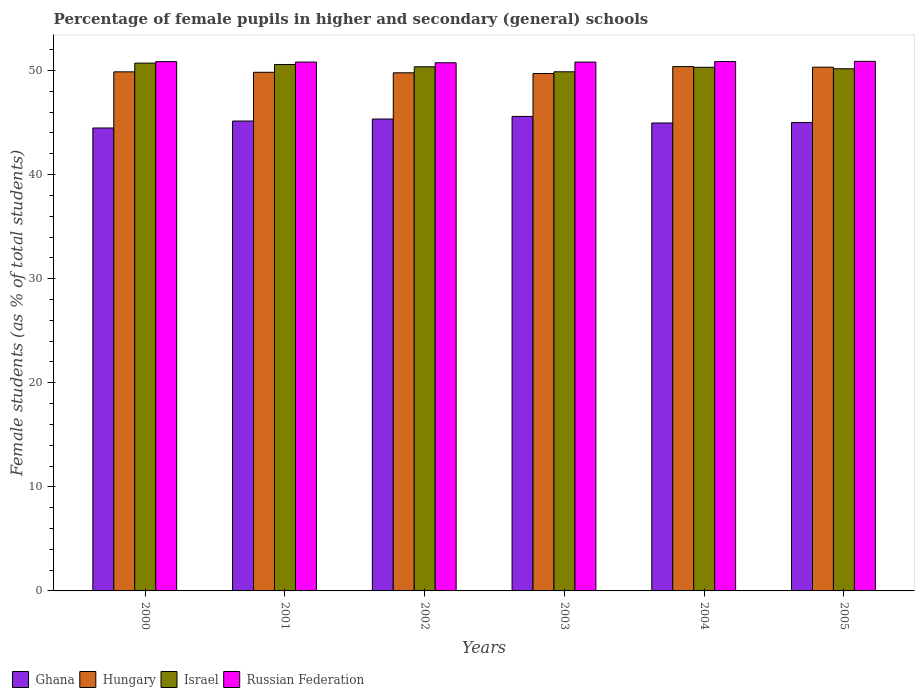What is the percentage of female pupils in higher and secondary schools in Ghana in 2003?
Offer a very short reply. 45.58. Across all years, what is the maximum percentage of female pupils in higher and secondary schools in Ghana?
Your answer should be compact. 45.58. Across all years, what is the minimum percentage of female pupils in higher and secondary schools in Ghana?
Your response must be concise. 44.47. In which year was the percentage of female pupils in higher and secondary schools in Hungary maximum?
Provide a succinct answer. 2004. In which year was the percentage of female pupils in higher and secondary schools in Russian Federation minimum?
Offer a terse response. 2002. What is the total percentage of female pupils in higher and secondary schools in Hungary in the graph?
Offer a very short reply. 299.85. What is the difference between the percentage of female pupils in higher and secondary schools in Hungary in 2000 and that in 2002?
Your answer should be very brief. 0.09. What is the difference between the percentage of female pupils in higher and secondary schools in Hungary in 2001 and the percentage of female pupils in higher and secondary schools in Ghana in 2002?
Offer a terse response. 4.49. What is the average percentage of female pupils in higher and secondary schools in Russian Federation per year?
Give a very brief answer. 50.82. In the year 2003, what is the difference between the percentage of female pupils in higher and secondary schools in Israel and percentage of female pupils in higher and secondary schools in Russian Federation?
Your answer should be very brief. -0.93. In how many years, is the percentage of female pupils in higher and secondary schools in Israel greater than 12 %?
Provide a succinct answer. 6. What is the ratio of the percentage of female pupils in higher and secondary schools in Israel in 2002 to that in 2003?
Provide a short and direct response. 1.01. Is the percentage of female pupils in higher and secondary schools in Israel in 2003 less than that in 2005?
Ensure brevity in your answer.  Yes. Is the difference between the percentage of female pupils in higher and secondary schools in Israel in 2000 and 2001 greater than the difference between the percentage of female pupils in higher and secondary schools in Russian Federation in 2000 and 2001?
Give a very brief answer. Yes. What is the difference between the highest and the second highest percentage of female pupils in higher and secondary schools in Israel?
Offer a very short reply. 0.13. What is the difference between the highest and the lowest percentage of female pupils in higher and secondary schools in Russian Federation?
Offer a terse response. 0.13. What does the 3rd bar from the left in 2003 represents?
Your answer should be very brief. Israel. What does the 1st bar from the right in 2001 represents?
Your response must be concise. Russian Federation. Is it the case that in every year, the sum of the percentage of female pupils in higher and secondary schools in Russian Federation and percentage of female pupils in higher and secondary schools in Hungary is greater than the percentage of female pupils in higher and secondary schools in Israel?
Your answer should be compact. Yes. What is the difference between two consecutive major ticks on the Y-axis?
Make the answer very short. 10. Does the graph contain any zero values?
Provide a short and direct response. No. Where does the legend appear in the graph?
Your answer should be very brief. Bottom left. How are the legend labels stacked?
Your answer should be compact. Horizontal. What is the title of the graph?
Offer a very short reply. Percentage of female pupils in higher and secondary (general) schools. Does "French Polynesia" appear as one of the legend labels in the graph?
Make the answer very short. No. What is the label or title of the X-axis?
Ensure brevity in your answer.  Years. What is the label or title of the Y-axis?
Provide a short and direct response. Female students (as % of total students). What is the Female students (as % of total students) in Ghana in 2000?
Give a very brief answer. 44.47. What is the Female students (as % of total students) of Hungary in 2000?
Provide a short and direct response. 49.87. What is the Female students (as % of total students) in Israel in 2000?
Offer a very short reply. 50.7. What is the Female students (as % of total students) in Russian Federation in 2000?
Provide a short and direct response. 50.85. What is the Female students (as % of total students) of Ghana in 2001?
Offer a terse response. 45.14. What is the Female students (as % of total students) in Hungary in 2001?
Your answer should be compact. 49.82. What is the Female students (as % of total students) of Israel in 2001?
Offer a very short reply. 50.57. What is the Female students (as % of total students) of Russian Federation in 2001?
Your response must be concise. 50.81. What is the Female students (as % of total students) in Ghana in 2002?
Your response must be concise. 45.33. What is the Female students (as % of total students) of Hungary in 2002?
Keep it short and to the point. 49.77. What is the Female students (as % of total students) in Israel in 2002?
Offer a terse response. 50.35. What is the Female students (as % of total students) of Russian Federation in 2002?
Ensure brevity in your answer.  50.74. What is the Female students (as % of total students) in Ghana in 2003?
Ensure brevity in your answer.  45.58. What is the Female students (as % of total students) of Hungary in 2003?
Provide a succinct answer. 49.71. What is the Female students (as % of total students) in Israel in 2003?
Your response must be concise. 49.87. What is the Female students (as % of total students) of Russian Federation in 2003?
Provide a short and direct response. 50.8. What is the Female students (as % of total students) of Ghana in 2004?
Offer a terse response. 44.95. What is the Female students (as % of total students) of Hungary in 2004?
Your answer should be compact. 50.37. What is the Female students (as % of total students) in Israel in 2004?
Your answer should be compact. 50.3. What is the Female students (as % of total students) of Russian Federation in 2004?
Provide a succinct answer. 50.85. What is the Female students (as % of total students) in Ghana in 2005?
Ensure brevity in your answer.  45. What is the Female students (as % of total students) in Hungary in 2005?
Ensure brevity in your answer.  50.31. What is the Female students (as % of total students) of Israel in 2005?
Give a very brief answer. 50.16. What is the Female students (as % of total students) in Russian Federation in 2005?
Provide a short and direct response. 50.87. Across all years, what is the maximum Female students (as % of total students) in Ghana?
Ensure brevity in your answer.  45.58. Across all years, what is the maximum Female students (as % of total students) in Hungary?
Provide a short and direct response. 50.37. Across all years, what is the maximum Female students (as % of total students) of Israel?
Your answer should be very brief. 50.7. Across all years, what is the maximum Female students (as % of total students) in Russian Federation?
Ensure brevity in your answer.  50.87. Across all years, what is the minimum Female students (as % of total students) of Ghana?
Your answer should be very brief. 44.47. Across all years, what is the minimum Female students (as % of total students) of Hungary?
Keep it short and to the point. 49.71. Across all years, what is the minimum Female students (as % of total students) of Israel?
Your response must be concise. 49.87. Across all years, what is the minimum Female students (as % of total students) of Russian Federation?
Your response must be concise. 50.74. What is the total Female students (as % of total students) in Ghana in the graph?
Your answer should be compact. 270.48. What is the total Female students (as % of total students) of Hungary in the graph?
Keep it short and to the point. 299.85. What is the total Female students (as % of total students) of Israel in the graph?
Keep it short and to the point. 301.96. What is the total Female students (as % of total students) in Russian Federation in the graph?
Ensure brevity in your answer.  304.93. What is the difference between the Female students (as % of total students) in Ghana in 2000 and that in 2001?
Give a very brief answer. -0.67. What is the difference between the Female students (as % of total students) in Hungary in 2000 and that in 2001?
Provide a succinct answer. 0.04. What is the difference between the Female students (as % of total students) of Israel in 2000 and that in 2001?
Your answer should be very brief. 0.13. What is the difference between the Female students (as % of total students) in Russian Federation in 2000 and that in 2001?
Provide a short and direct response. 0.04. What is the difference between the Female students (as % of total students) in Ghana in 2000 and that in 2002?
Offer a terse response. -0.86. What is the difference between the Female students (as % of total students) in Hungary in 2000 and that in 2002?
Your answer should be very brief. 0.09. What is the difference between the Female students (as % of total students) of Israel in 2000 and that in 2002?
Your answer should be very brief. 0.35. What is the difference between the Female students (as % of total students) in Russian Federation in 2000 and that in 2002?
Your answer should be very brief. 0.11. What is the difference between the Female students (as % of total students) of Ghana in 2000 and that in 2003?
Ensure brevity in your answer.  -1.11. What is the difference between the Female students (as % of total students) of Hungary in 2000 and that in 2003?
Ensure brevity in your answer.  0.16. What is the difference between the Female students (as % of total students) of Russian Federation in 2000 and that in 2003?
Your answer should be very brief. 0.05. What is the difference between the Female students (as % of total students) of Ghana in 2000 and that in 2004?
Your answer should be very brief. -0.48. What is the difference between the Female students (as % of total students) in Hungary in 2000 and that in 2004?
Your answer should be compact. -0.5. What is the difference between the Female students (as % of total students) in Israel in 2000 and that in 2004?
Provide a succinct answer. 0.4. What is the difference between the Female students (as % of total students) in Russian Federation in 2000 and that in 2004?
Make the answer very short. -0. What is the difference between the Female students (as % of total students) in Ghana in 2000 and that in 2005?
Give a very brief answer. -0.53. What is the difference between the Female students (as % of total students) in Hungary in 2000 and that in 2005?
Make the answer very short. -0.45. What is the difference between the Female students (as % of total students) in Israel in 2000 and that in 2005?
Ensure brevity in your answer.  0.54. What is the difference between the Female students (as % of total students) in Russian Federation in 2000 and that in 2005?
Ensure brevity in your answer.  -0.02. What is the difference between the Female students (as % of total students) of Ghana in 2001 and that in 2002?
Offer a terse response. -0.19. What is the difference between the Female students (as % of total students) in Hungary in 2001 and that in 2002?
Make the answer very short. 0.05. What is the difference between the Female students (as % of total students) of Israel in 2001 and that in 2002?
Offer a terse response. 0.22. What is the difference between the Female students (as % of total students) of Russian Federation in 2001 and that in 2002?
Keep it short and to the point. 0.07. What is the difference between the Female students (as % of total students) in Ghana in 2001 and that in 2003?
Your answer should be compact. -0.44. What is the difference between the Female students (as % of total students) in Hungary in 2001 and that in 2003?
Make the answer very short. 0.12. What is the difference between the Female students (as % of total students) in Israel in 2001 and that in 2003?
Provide a short and direct response. 0.7. What is the difference between the Female students (as % of total students) of Russian Federation in 2001 and that in 2003?
Provide a short and direct response. 0. What is the difference between the Female students (as % of total students) of Ghana in 2001 and that in 2004?
Provide a succinct answer. 0.19. What is the difference between the Female students (as % of total students) in Hungary in 2001 and that in 2004?
Your answer should be very brief. -0.55. What is the difference between the Female students (as % of total students) in Israel in 2001 and that in 2004?
Give a very brief answer. 0.27. What is the difference between the Female students (as % of total students) in Russian Federation in 2001 and that in 2004?
Provide a short and direct response. -0.05. What is the difference between the Female students (as % of total students) of Ghana in 2001 and that in 2005?
Give a very brief answer. 0.14. What is the difference between the Female students (as % of total students) in Hungary in 2001 and that in 2005?
Your answer should be very brief. -0.49. What is the difference between the Female students (as % of total students) in Israel in 2001 and that in 2005?
Your answer should be compact. 0.41. What is the difference between the Female students (as % of total students) of Russian Federation in 2001 and that in 2005?
Provide a short and direct response. -0.07. What is the difference between the Female students (as % of total students) of Ghana in 2002 and that in 2003?
Your response must be concise. -0.25. What is the difference between the Female students (as % of total students) of Hungary in 2002 and that in 2003?
Provide a short and direct response. 0.07. What is the difference between the Female students (as % of total students) in Israel in 2002 and that in 2003?
Provide a succinct answer. 0.48. What is the difference between the Female students (as % of total students) in Russian Federation in 2002 and that in 2003?
Keep it short and to the point. -0.06. What is the difference between the Female students (as % of total students) of Ghana in 2002 and that in 2004?
Ensure brevity in your answer.  0.38. What is the difference between the Female students (as % of total students) of Hungary in 2002 and that in 2004?
Your answer should be compact. -0.6. What is the difference between the Female students (as % of total students) in Israel in 2002 and that in 2004?
Your answer should be compact. 0.05. What is the difference between the Female students (as % of total students) of Russian Federation in 2002 and that in 2004?
Keep it short and to the point. -0.11. What is the difference between the Female students (as % of total students) of Ghana in 2002 and that in 2005?
Keep it short and to the point. 0.33. What is the difference between the Female students (as % of total students) of Hungary in 2002 and that in 2005?
Your answer should be very brief. -0.54. What is the difference between the Female students (as % of total students) in Israel in 2002 and that in 2005?
Your answer should be compact. 0.19. What is the difference between the Female students (as % of total students) of Russian Federation in 2002 and that in 2005?
Your answer should be very brief. -0.13. What is the difference between the Female students (as % of total students) in Ghana in 2003 and that in 2004?
Your answer should be compact. 0.63. What is the difference between the Female students (as % of total students) in Hungary in 2003 and that in 2004?
Provide a succinct answer. -0.66. What is the difference between the Female students (as % of total students) of Israel in 2003 and that in 2004?
Your answer should be compact. -0.43. What is the difference between the Female students (as % of total students) in Russian Federation in 2003 and that in 2004?
Your response must be concise. -0.05. What is the difference between the Female students (as % of total students) in Ghana in 2003 and that in 2005?
Keep it short and to the point. 0.58. What is the difference between the Female students (as % of total students) in Hungary in 2003 and that in 2005?
Your answer should be very brief. -0.61. What is the difference between the Female students (as % of total students) in Israel in 2003 and that in 2005?
Ensure brevity in your answer.  -0.29. What is the difference between the Female students (as % of total students) in Russian Federation in 2003 and that in 2005?
Provide a succinct answer. -0.07. What is the difference between the Female students (as % of total students) of Ghana in 2004 and that in 2005?
Offer a very short reply. -0.05. What is the difference between the Female students (as % of total students) in Hungary in 2004 and that in 2005?
Your answer should be very brief. 0.06. What is the difference between the Female students (as % of total students) in Israel in 2004 and that in 2005?
Give a very brief answer. 0.14. What is the difference between the Female students (as % of total students) of Russian Federation in 2004 and that in 2005?
Keep it short and to the point. -0.02. What is the difference between the Female students (as % of total students) in Ghana in 2000 and the Female students (as % of total students) in Hungary in 2001?
Provide a short and direct response. -5.35. What is the difference between the Female students (as % of total students) of Ghana in 2000 and the Female students (as % of total students) of Israel in 2001?
Your answer should be very brief. -6.1. What is the difference between the Female students (as % of total students) of Ghana in 2000 and the Female students (as % of total students) of Russian Federation in 2001?
Give a very brief answer. -6.33. What is the difference between the Female students (as % of total students) in Hungary in 2000 and the Female students (as % of total students) in Israel in 2001?
Provide a succinct answer. -0.71. What is the difference between the Female students (as % of total students) of Hungary in 2000 and the Female students (as % of total students) of Russian Federation in 2001?
Ensure brevity in your answer.  -0.94. What is the difference between the Female students (as % of total students) in Israel in 2000 and the Female students (as % of total students) in Russian Federation in 2001?
Provide a short and direct response. -0.1. What is the difference between the Female students (as % of total students) in Ghana in 2000 and the Female students (as % of total students) in Hungary in 2002?
Give a very brief answer. -5.3. What is the difference between the Female students (as % of total students) in Ghana in 2000 and the Female students (as % of total students) in Israel in 2002?
Provide a succinct answer. -5.88. What is the difference between the Female students (as % of total students) of Ghana in 2000 and the Female students (as % of total students) of Russian Federation in 2002?
Keep it short and to the point. -6.27. What is the difference between the Female students (as % of total students) in Hungary in 2000 and the Female students (as % of total students) in Israel in 2002?
Your response must be concise. -0.49. What is the difference between the Female students (as % of total students) in Hungary in 2000 and the Female students (as % of total students) in Russian Federation in 2002?
Offer a very short reply. -0.88. What is the difference between the Female students (as % of total students) in Israel in 2000 and the Female students (as % of total students) in Russian Federation in 2002?
Give a very brief answer. -0.04. What is the difference between the Female students (as % of total students) in Ghana in 2000 and the Female students (as % of total students) in Hungary in 2003?
Keep it short and to the point. -5.23. What is the difference between the Female students (as % of total students) of Ghana in 2000 and the Female students (as % of total students) of Israel in 2003?
Your response must be concise. -5.4. What is the difference between the Female students (as % of total students) of Ghana in 2000 and the Female students (as % of total students) of Russian Federation in 2003?
Make the answer very short. -6.33. What is the difference between the Female students (as % of total students) of Hungary in 2000 and the Female students (as % of total students) of Israel in 2003?
Provide a short and direct response. -0. What is the difference between the Female students (as % of total students) in Hungary in 2000 and the Female students (as % of total students) in Russian Federation in 2003?
Your answer should be very brief. -0.94. What is the difference between the Female students (as % of total students) in Israel in 2000 and the Female students (as % of total students) in Russian Federation in 2003?
Ensure brevity in your answer.  -0.1. What is the difference between the Female students (as % of total students) in Ghana in 2000 and the Female students (as % of total students) in Hungary in 2004?
Your response must be concise. -5.9. What is the difference between the Female students (as % of total students) of Ghana in 2000 and the Female students (as % of total students) of Israel in 2004?
Provide a short and direct response. -5.83. What is the difference between the Female students (as % of total students) in Ghana in 2000 and the Female students (as % of total students) in Russian Federation in 2004?
Keep it short and to the point. -6.38. What is the difference between the Female students (as % of total students) of Hungary in 2000 and the Female students (as % of total students) of Israel in 2004?
Your response must be concise. -0.44. What is the difference between the Female students (as % of total students) of Hungary in 2000 and the Female students (as % of total students) of Russian Federation in 2004?
Keep it short and to the point. -0.99. What is the difference between the Female students (as % of total students) in Israel in 2000 and the Female students (as % of total students) in Russian Federation in 2004?
Give a very brief answer. -0.15. What is the difference between the Female students (as % of total students) of Ghana in 2000 and the Female students (as % of total students) of Hungary in 2005?
Make the answer very short. -5.84. What is the difference between the Female students (as % of total students) in Ghana in 2000 and the Female students (as % of total students) in Israel in 2005?
Keep it short and to the point. -5.69. What is the difference between the Female students (as % of total students) in Ghana in 2000 and the Female students (as % of total students) in Russian Federation in 2005?
Give a very brief answer. -6.4. What is the difference between the Female students (as % of total students) in Hungary in 2000 and the Female students (as % of total students) in Israel in 2005?
Give a very brief answer. -0.3. What is the difference between the Female students (as % of total students) of Hungary in 2000 and the Female students (as % of total students) of Russian Federation in 2005?
Your response must be concise. -1.01. What is the difference between the Female students (as % of total students) of Israel in 2000 and the Female students (as % of total students) of Russian Federation in 2005?
Keep it short and to the point. -0.17. What is the difference between the Female students (as % of total students) in Ghana in 2001 and the Female students (as % of total students) in Hungary in 2002?
Offer a terse response. -4.63. What is the difference between the Female students (as % of total students) in Ghana in 2001 and the Female students (as % of total students) in Israel in 2002?
Provide a succinct answer. -5.21. What is the difference between the Female students (as % of total students) in Ghana in 2001 and the Female students (as % of total students) in Russian Federation in 2002?
Provide a succinct answer. -5.6. What is the difference between the Female students (as % of total students) of Hungary in 2001 and the Female students (as % of total students) of Israel in 2002?
Your answer should be compact. -0.53. What is the difference between the Female students (as % of total students) of Hungary in 2001 and the Female students (as % of total students) of Russian Federation in 2002?
Your answer should be compact. -0.92. What is the difference between the Female students (as % of total students) of Israel in 2001 and the Female students (as % of total students) of Russian Federation in 2002?
Give a very brief answer. -0.17. What is the difference between the Female students (as % of total students) of Ghana in 2001 and the Female students (as % of total students) of Hungary in 2003?
Your answer should be very brief. -4.57. What is the difference between the Female students (as % of total students) of Ghana in 2001 and the Female students (as % of total students) of Israel in 2003?
Keep it short and to the point. -4.73. What is the difference between the Female students (as % of total students) of Ghana in 2001 and the Female students (as % of total students) of Russian Federation in 2003?
Provide a short and direct response. -5.66. What is the difference between the Female students (as % of total students) of Hungary in 2001 and the Female students (as % of total students) of Israel in 2003?
Your answer should be very brief. -0.05. What is the difference between the Female students (as % of total students) in Hungary in 2001 and the Female students (as % of total students) in Russian Federation in 2003?
Your answer should be compact. -0.98. What is the difference between the Female students (as % of total students) of Israel in 2001 and the Female students (as % of total students) of Russian Federation in 2003?
Offer a very short reply. -0.23. What is the difference between the Female students (as % of total students) of Ghana in 2001 and the Female students (as % of total students) of Hungary in 2004?
Offer a very short reply. -5.23. What is the difference between the Female students (as % of total students) of Ghana in 2001 and the Female students (as % of total students) of Israel in 2004?
Give a very brief answer. -5.16. What is the difference between the Female students (as % of total students) in Ghana in 2001 and the Female students (as % of total students) in Russian Federation in 2004?
Offer a terse response. -5.71. What is the difference between the Female students (as % of total students) of Hungary in 2001 and the Female students (as % of total students) of Israel in 2004?
Provide a short and direct response. -0.48. What is the difference between the Female students (as % of total students) of Hungary in 2001 and the Female students (as % of total students) of Russian Federation in 2004?
Provide a succinct answer. -1.03. What is the difference between the Female students (as % of total students) of Israel in 2001 and the Female students (as % of total students) of Russian Federation in 2004?
Your answer should be very brief. -0.28. What is the difference between the Female students (as % of total students) in Ghana in 2001 and the Female students (as % of total students) in Hungary in 2005?
Your answer should be very brief. -5.17. What is the difference between the Female students (as % of total students) in Ghana in 2001 and the Female students (as % of total students) in Israel in 2005?
Your answer should be compact. -5.02. What is the difference between the Female students (as % of total students) in Ghana in 2001 and the Female students (as % of total students) in Russian Federation in 2005?
Keep it short and to the point. -5.73. What is the difference between the Female students (as % of total students) in Hungary in 2001 and the Female students (as % of total students) in Israel in 2005?
Ensure brevity in your answer.  -0.34. What is the difference between the Female students (as % of total students) in Hungary in 2001 and the Female students (as % of total students) in Russian Federation in 2005?
Keep it short and to the point. -1.05. What is the difference between the Female students (as % of total students) in Israel in 2001 and the Female students (as % of total students) in Russian Federation in 2005?
Offer a terse response. -0.3. What is the difference between the Female students (as % of total students) of Ghana in 2002 and the Female students (as % of total students) of Hungary in 2003?
Give a very brief answer. -4.37. What is the difference between the Female students (as % of total students) of Ghana in 2002 and the Female students (as % of total students) of Israel in 2003?
Keep it short and to the point. -4.54. What is the difference between the Female students (as % of total students) of Ghana in 2002 and the Female students (as % of total students) of Russian Federation in 2003?
Give a very brief answer. -5.47. What is the difference between the Female students (as % of total students) in Hungary in 2002 and the Female students (as % of total students) in Israel in 2003?
Offer a terse response. -0.1. What is the difference between the Female students (as % of total students) of Hungary in 2002 and the Female students (as % of total students) of Russian Federation in 2003?
Keep it short and to the point. -1.03. What is the difference between the Female students (as % of total students) in Israel in 2002 and the Female students (as % of total students) in Russian Federation in 2003?
Your answer should be very brief. -0.45. What is the difference between the Female students (as % of total students) of Ghana in 2002 and the Female students (as % of total students) of Hungary in 2004?
Keep it short and to the point. -5.04. What is the difference between the Female students (as % of total students) of Ghana in 2002 and the Female students (as % of total students) of Israel in 2004?
Your answer should be compact. -4.97. What is the difference between the Female students (as % of total students) in Ghana in 2002 and the Female students (as % of total students) in Russian Federation in 2004?
Ensure brevity in your answer.  -5.52. What is the difference between the Female students (as % of total students) in Hungary in 2002 and the Female students (as % of total students) in Israel in 2004?
Make the answer very short. -0.53. What is the difference between the Female students (as % of total students) in Hungary in 2002 and the Female students (as % of total students) in Russian Federation in 2004?
Your answer should be compact. -1.08. What is the difference between the Female students (as % of total students) in Israel in 2002 and the Female students (as % of total students) in Russian Federation in 2004?
Provide a succinct answer. -0.5. What is the difference between the Female students (as % of total students) of Ghana in 2002 and the Female students (as % of total students) of Hungary in 2005?
Your answer should be compact. -4.98. What is the difference between the Female students (as % of total students) of Ghana in 2002 and the Female students (as % of total students) of Israel in 2005?
Ensure brevity in your answer.  -4.83. What is the difference between the Female students (as % of total students) in Ghana in 2002 and the Female students (as % of total students) in Russian Federation in 2005?
Keep it short and to the point. -5.54. What is the difference between the Female students (as % of total students) in Hungary in 2002 and the Female students (as % of total students) in Israel in 2005?
Provide a succinct answer. -0.39. What is the difference between the Female students (as % of total students) of Hungary in 2002 and the Female students (as % of total students) of Russian Federation in 2005?
Give a very brief answer. -1.1. What is the difference between the Female students (as % of total students) in Israel in 2002 and the Female students (as % of total students) in Russian Federation in 2005?
Your answer should be very brief. -0.52. What is the difference between the Female students (as % of total students) in Ghana in 2003 and the Female students (as % of total students) in Hungary in 2004?
Your answer should be very brief. -4.79. What is the difference between the Female students (as % of total students) in Ghana in 2003 and the Female students (as % of total students) in Israel in 2004?
Ensure brevity in your answer.  -4.72. What is the difference between the Female students (as % of total students) in Ghana in 2003 and the Female students (as % of total students) in Russian Federation in 2004?
Ensure brevity in your answer.  -5.27. What is the difference between the Female students (as % of total students) in Hungary in 2003 and the Female students (as % of total students) in Israel in 2004?
Your answer should be compact. -0.6. What is the difference between the Female students (as % of total students) in Hungary in 2003 and the Female students (as % of total students) in Russian Federation in 2004?
Offer a very short reply. -1.15. What is the difference between the Female students (as % of total students) in Israel in 2003 and the Female students (as % of total students) in Russian Federation in 2004?
Offer a terse response. -0.98. What is the difference between the Female students (as % of total students) of Ghana in 2003 and the Female students (as % of total students) of Hungary in 2005?
Provide a succinct answer. -4.73. What is the difference between the Female students (as % of total students) of Ghana in 2003 and the Female students (as % of total students) of Israel in 2005?
Ensure brevity in your answer.  -4.58. What is the difference between the Female students (as % of total students) in Ghana in 2003 and the Female students (as % of total students) in Russian Federation in 2005?
Provide a short and direct response. -5.29. What is the difference between the Female students (as % of total students) in Hungary in 2003 and the Female students (as % of total students) in Israel in 2005?
Your answer should be compact. -0.46. What is the difference between the Female students (as % of total students) in Hungary in 2003 and the Female students (as % of total students) in Russian Federation in 2005?
Your response must be concise. -1.17. What is the difference between the Female students (as % of total students) in Israel in 2003 and the Female students (as % of total students) in Russian Federation in 2005?
Your answer should be compact. -1. What is the difference between the Female students (as % of total students) of Ghana in 2004 and the Female students (as % of total students) of Hungary in 2005?
Make the answer very short. -5.36. What is the difference between the Female students (as % of total students) of Ghana in 2004 and the Female students (as % of total students) of Israel in 2005?
Keep it short and to the point. -5.21. What is the difference between the Female students (as % of total students) in Ghana in 2004 and the Female students (as % of total students) in Russian Federation in 2005?
Offer a very short reply. -5.92. What is the difference between the Female students (as % of total students) of Hungary in 2004 and the Female students (as % of total students) of Israel in 2005?
Give a very brief answer. 0.21. What is the difference between the Female students (as % of total students) in Hungary in 2004 and the Female students (as % of total students) in Russian Federation in 2005?
Make the answer very short. -0.5. What is the difference between the Female students (as % of total students) in Israel in 2004 and the Female students (as % of total students) in Russian Federation in 2005?
Ensure brevity in your answer.  -0.57. What is the average Female students (as % of total students) in Ghana per year?
Offer a terse response. 45.08. What is the average Female students (as % of total students) in Hungary per year?
Give a very brief answer. 49.98. What is the average Female students (as % of total students) in Israel per year?
Your answer should be compact. 50.33. What is the average Female students (as % of total students) of Russian Federation per year?
Provide a succinct answer. 50.82. In the year 2000, what is the difference between the Female students (as % of total students) of Ghana and Female students (as % of total students) of Hungary?
Your answer should be very brief. -5.39. In the year 2000, what is the difference between the Female students (as % of total students) in Ghana and Female students (as % of total students) in Israel?
Give a very brief answer. -6.23. In the year 2000, what is the difference between the Female students (as % of total students) in Ghana and Female students (as % of total students) in Russian Federation?
Offer a terse response. -6.38. In the year 2000, what is the difference between the Female students (as % of total students) in Hungary and Female students (as % of total students) in Israel?
Make the answer very short. -0.84. In the year 2000, what is the difference between the Female students (as % of total students) in Hungary and Female students (as % of total students) in Russian Federation?
Offer a very short reply. -0.98. In the year 2000, what is the difference between the Female students (as % of total students) of Israel and Female students (as % of total students) of Russian Federation?
Ensure brevity in your answer.  -0.15. In the year 2001, what is the difference between the Female students (as % of total students) of Ghana and Female students (as % of total students) of Hungary?
Keep it short and to the point. -4.68. In the year 2001, what is the difference between the Female students (as % of total students) in Ghana and Female students (as % of total students) in Israel?
Provide a short and direct response. -5.43. In the year 2001, what is the difference between the Female students (as % of total students) of Ghana and Female students (as % of total students) of Russian Federation?
Provide a short and direct response. -5.67. In the year 2001, what is the difference between the Female students (as % of total students) in Hungary and Female students (as % of total students) in Israel?
Provide a short and direct response. -0.75. In the year 2001, what is the difference between the Female students (as % of total students) in Hungary and Female students (as % of total students) in Russian Federation?
Make the answer very short. -0.98. In the year 2001, what is the difference between the Female students (as % of total students) of Israel and Female students (as % of total students) of Russian Federation?
Offer a very short reply. -0.23. In the year 2002, what is the difference between the Female students (as % of total students) in Ghana and Female students (as % of total students) in Hungary?
Give a very brief answer. -4.44. In the year 2002, what is the difference between the Female students (as % of total students) in Ghana and Female students (as % of total students) in Israel?
Offer a very short reply. -5.02. In the year 2002, what is the difference between the Female students (as % of total students) of Ghana and Female students (as % of total students) of Russian Federation?
Offer a very short reply. -5.41. In the year 2002, what is the difference between the Female students (as % of total students) in Hungary and Female students (as % of total students) in Israel?
Your answer should be very brief. -0.58. In the year 2002, what is the difference between the Female students (as % of total students) of Hungary and Female students (as % of total students) of Russian Federation?
Keep it short and to the point. -0.97. In the year 2002, what is the difference between the Female students (as % of total students) of Israel and Female students (as % of total students) of Russian Federation?
Ensure brevity in your answer.  -0.39. In the year 2003, what is the difference between the Female students (as % of total students) of Ghana and Female students (as % of total students) of Hungary?
Offer a very short reply. -4.12. In the year 2003, what is the difference between the Female students (as % of total students) in Ghana and Female students (as % of total students) in Israel?
Your answer should be compact. -4.29. In the year 2003, what is the difference between the Female students (as % of total students) in Ghana and Female students (as % of total students) in Russian Federation?
Your answer should be very brief. -5.22. In the year 2003, what is the difference between the Female students (as % of total students) of Hungary and Female students (as % of total students) of Israel?
Ensure brevity in your answer.  -0.16. In the year 2003, what is the difference between the Female students (as % of total students) of Hungary and Female students (as % of total students) of Russian Federation?
Your response must be concise. -1.1. In the year 2003, what is the difference between the Female students (as % of total students) of Israel and Female students (as % of total students) of Russian Federation?
Your response must be concise. -0.93. In the year 2004, what is the difference between the Female students (as % of total students) in Ghana and Female students (as % of total students) in Hungary?
Provide a succinct answer. -5.42. In the year 2004, what is the difference between the Female students (as % of total students) in Ghana and Female students (as % of total students) in Israel?
Your answer should be compact. -5.35. In the year 2004, what is the difference between the Female students (as % of total students) in Ghana and Female students (as % of total students) in Russian Federation?
Keep it short and to the point. -5.9. In the year 2004, what is the difference between the Female students (as % of total students) in Hungary and Female students (as % of total students) in Israel?
Keep it short and to the point. 0.07. In the year 2004, what is the difference between the Female students (as % of total students) in Hungary and Female students (as % of total students) in Russian Federation?
Give a very brief answer. -0.48. In the year 2004, what is the difference between the Female students (as % of total students) of Israel and Female students (as % of total students) of Russian Federation?
Give a very brief answer. -0.55. In the year 2005, what is the difference between the Female students (as % of total students) in Ghana and Female students (as % of total students) in Hungary?
Your answer should be compact. -5.31. In the year 2005, what is the difference between the Female students (as % of total students) in Ghana and Female students (as % of total students) in Israel?
Your response must be concise. -5.16. In the year 2005, what is the difference between the Female students (as % of total students) in Ghana and Female students (as % of total students) in Russian Federation?
Your answer should be very brief. -5.87. In the year 2005, what is the difference between the Female students (as % of total students) of Hungary and Female students (as % of total students) of Israel?
Your answer should be very brief. 0.15. In the year 2005, what is the difference between the Female students (as % of total students) in Hungary and Female students (as % of total students) in Russian Federation?
Keep it short and to the point. -0.56. In the year 2005, what is the difference between the Female students (as % of total students) in Israel and Female students (as % of total students) in Russian Federation?
Make the answer very short. -0.71. What is the ratio of the Female students (as % of total students) of Ghana in 2000 to that in 2001?
Make the answer very short. 0.99. What is the ratio of the Female students (as % of total students) in Hungary in 2000 to that in 2001?
Provide a short and direct response. 1. What is the ratio of the Female students (as % of total students) in Russian Federation in 2000 to that in 2001?
Provide a succinct answer. 1. What is the ratio of the Female students (as % of total students) in Ghana in 2000 to that in 2002?
Keep it short and to the point. 0.98. What is the ratio of the Female students (as % of total students) of Israel in 2000 to that in 2002?
Your response must be concise. 1.01. What is the ratio of the Female students (as % of total students) in Russian Federation in 2000 to that in 2002?
Make the answer very short. 1. What is the ratio of the Female students (as % of total students) in Ghana in 2000 to that in 2003?
Your answer should be very brief. 0.98. What is the ratio of the Female students (as % of total students) in Hungary in 2000 to that in 2003?
Offer a terse response. 1. What is the ratio of the Female students (as % of total students) of Israel in 2000 to that in 2003?
Provide a succinct answer. 1.02. What is the ratio of the Female students (as % of total students) in Russian Federation in 2000 to that in 2003?
Provide a succinct answer. 1. What is the ratio of the Female students (as % of total students) in Ghana in 2000 to that in 2004?
Make the answer very short. 0.99. What is the ratio of the Female students (as % of total students) of Hungary in 2000 to that in 2004?
Offer a very short reply. 0.99. What is the ratio of the Female students (as % of total students) of Israel in 2000 to that in 2004?
Your response must be concise. 1.01. What is the ratio of the Female students (as % of total students) of Ghana in 2000 to that in 2005?
Your answer should be compact. 0.99. What is the ratio of the Female students (as % of total students) of Israel in 2000 to that in 2005?
Your answer should be very brief. 1.01. What is the ratio of the Female students (as % of total students) of Ghana in 2001 to that in 2002?
Offer a terse response. 1. What is the ratio of the Female students (as % of total students) of Israel in 2001 to that in 2002?
Your response must be concise. 1. What is the ratio of the Female students (as % of total students) of Russian Federation in 2001 to that in 2002?
Your answer should be very brief. 1. What is the ratio of the Female students (as % of total students) of Ghana in 2001 to that in 2003?
Your answer should be compact. 0.99. What is the ratio of the Female students (as % of total students) of Israel in 2001 to that in 2003?
Provide a short and direct response. 1.01. What is the ratio of the Female students (as % of total students) in Russian Federation in 2001 to that in 2003?
Provide a succinct answer. 1. What is the ratio of the Female students (as % of total students) in Israel in 2001 to that in 2004?
Ensure brevity in your answer.  1.01. What is the ratio of the Female students (as % of total students) in Hungary in 2001 to that in 2005?
Your answer should be compact. 0.99. What is the ratio of the Female students (as % of total students) of Israel in 2001 to that in 2005?
Ensure brevity in your answer.  1.01. What is the ratio of the Female students (as % of total students) of Hungary in 2002 to that in 2003?
Your response must be concise. 1. What is the ratio of the Female students (as % of total students) of Israel in 2002 to that in 2003?
Give a very brief answer. 1.01. What is the ratio of the Female students (as % of total students) in Ghana in 2002 to that in 2004?
Make the answer very short. 1.01. What is the ratio of the Female students (as % of total students) in Ghana in 2002 to that in 2005?
Provide a short and direct response. 1.01. What is the ratio of the Female students (as % of total students) of Hungary in 2002 to that in 2005?
Give a very brief answer. 0.99. What is the ratio of the Female students (as % of total students) in Israel in 2002 to that in 2005?
Your answer should be compact. 1. What is the ratio of the Female students (as % of total students) in Ghana in 2003 to that in 2004?
Keep it short and to the point. 1.01. What is the ratio of the Female students (as % of total students) of Hungary in 2003 to that in 2004?
Provide a short and direct response. 0.99. What is the ratio of the Female students (as % of total students) in Russian Federation in 2003 to that in 2004?
Your answer should be compact. 1. What is the ratio of the Female students (as % of total students) of Ghana in 2003 to that in 2005?
Provide a succinct answer. 1.01. What is the ratio of the Female students (as % of total students) of Ghana in 2004 to that in 2005?
Make the answer very short. 1. What is the difference between the highest and the second highest Female students (as % of total students) in Ghana?
Your response must be concise. 0.25. What is the difference between the highest and the second highest Female students (as % of total students) of Hungary?
Offer a very short reply. 0.06. What is the difference between the highest and the second highest Female students (as % of total students) in Israel?
Provide a succinct answer. 0.13. What is the difference between the highest and the second highest Female students (as % of total students) of Russian Federation?
Make the answer very short. 0.02. What is the difference between the highest and the lowest Female students (as % of total students) in Ghana?
Your response must be concise. 1.11. What is the difference between the highest and the lowest Female students (as % of total students) in Hungary?
Your response must be concise. 0.66. What is the difference between the highest and the lowest Female students (as % of total students) of Russian Federation?
Provide a short and direct response. 0.13. 